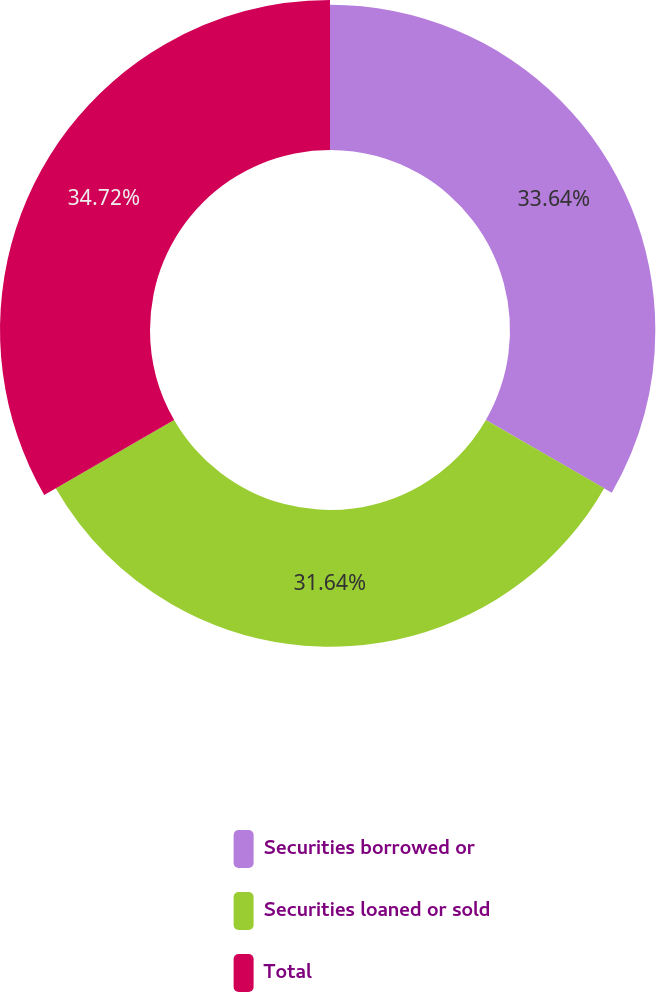Convert chart to OTSL. <chart><loc_0><loc_0><loc_500><loc_500><pie_chart><fcel>Securities borrowed or<fcel>Securities loaned or sold<fcel>Total<nl><fcel>33.64%<fcel>31.64%<fcel>34.72%<nl></chart> 